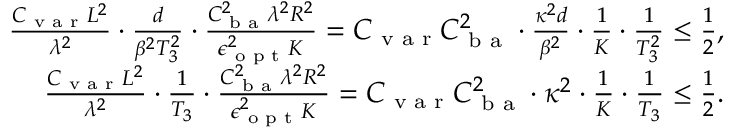Convert formula to latex. <formula><loc_0><loc_0><loc_500><loc_500>\begin{array} { r } { \frac { C _ { v a r } L ^ { 2 } } { \lambda ^ { 2 } } \cdot \frac { d } { \beta ^ { 2 } T _ { 3 } ^ { 2 } } \cdot \frac { C _ { b a } ^ { 2 } \lambda ^ { 2 } R ^ { 2 } } { \epsilon _ { o p t } ^ { 2 } K } = C _ { v a r } C _ { b a } ^ { 2 } \cdot \frac { \kappa ^ { 2 } d } { \beta ^ { 2 } } \cdot \frac { 1 } { K } \cdot \frac { 1 } T _ { 3 } ^ { 2 } } \leq \frac { 1 } { 2 } , } \\ { \frac { C _ { v a r } L ^ { 2 } } { \lambda ^ { 2 } } \cdot \frac { 1 } { T _ { 3 } } \cdot \frac { C _ { b a } ^ { 2 } \lambda ^ { 2 } R ^ { 2 } } { \epsilon _ { o p t } ^ { 2 } K } = C _ { v a r } C _ { b a } ^ { 2 } \cdot \kappa ^ { 2 } \cdot \frac { 1 } { K } \cdot \frac { 1 } T _ { 3 } } \leq \frac { 1 } { 2 } . } \end{array}</formula> 